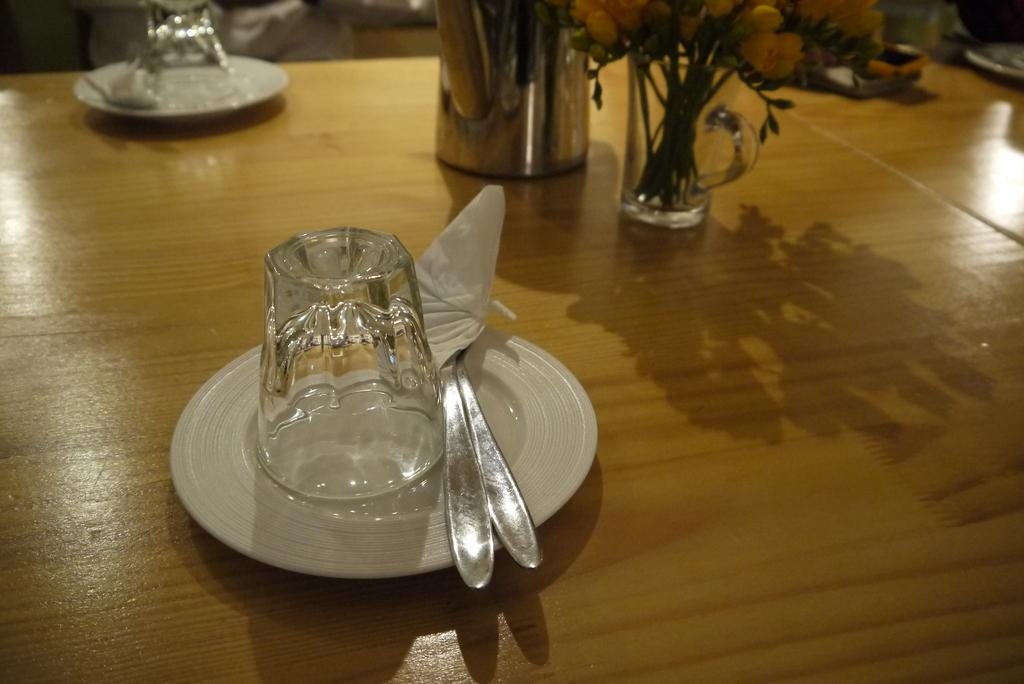What is on the plate in the image? There is a spoon and a glass on the plate in the image. What else can be seen on the dining table besides the plate? There is tissue on the dining table. Where is the flower vase located in the image? The flower vase is on the top right side of the image. What type of surface is the plate, spoon, glass, and tissue resting on? They are resting on a dining table. How many houses are visible in the image? There are no houses visible in the image; it features a plate, spoon, glass, tissue, and a flower vase on a dining table. What type of property is being sold in the image? There is no property being sold in the image; it is a still life of objects on a dining table. 